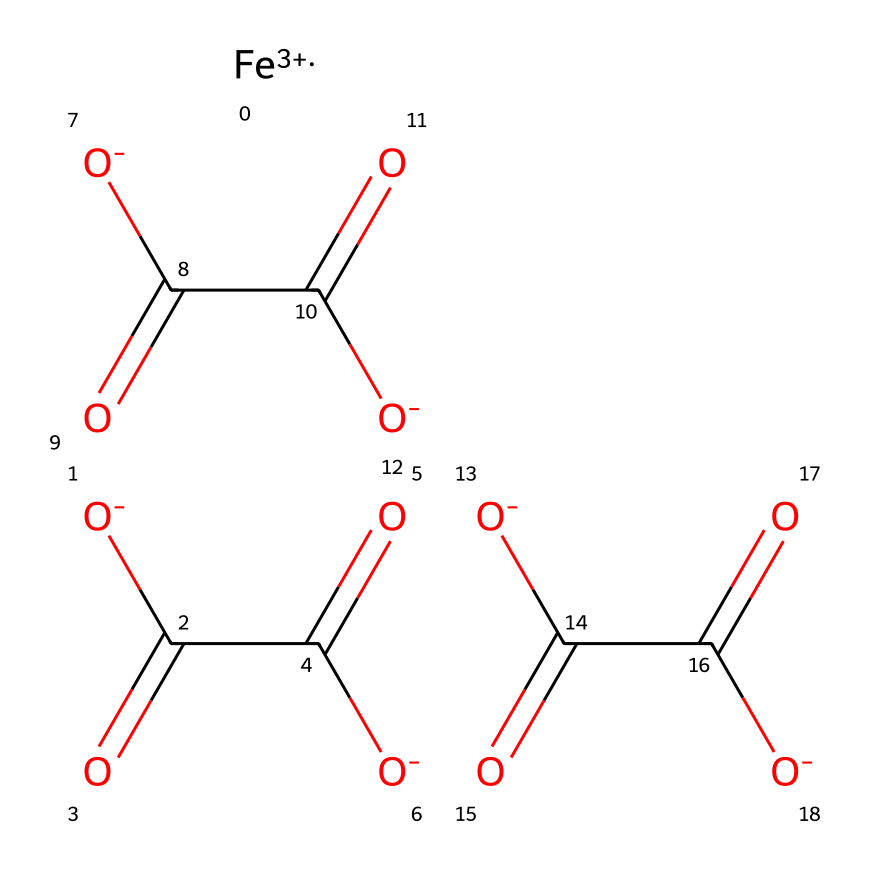What is the central metal ion in this coordination compound? The central metal ion can be identified by looking for the positively charged species in the structure. In this case, the positive charge corresponds to the iron (Fe) in the oxidation state of +3.
Answer: iron(III) How many oxalate ligands are present in the structure? The oxalate ligand is represented by the segment “C(=O)C(=O)[O-]”, which appears three times in the structure. Thus, we can count three instances of this ligand.
Answer: three What type of coordination environment does iron(III) have in this compound? The coordination environment can be discerned by examining the number of ligands attached to the central metal ion. Here, iron(III) is coordinated to three bidentate oxalate ligands, indicating an octahedral coordination geometry.
Answer: octahedral What is the overall charge of the coordination compound? To determine the overall charge, we sum the charges of the central metal and the ligands. Iron(III) contributes +3, and each oxalate contributes -2 for a total of -6 from three oxalate ligands. Thus, the overall charge is +3 - 6 = -3.
Answer: -3 How does the presence of oxalate ligands influence the properties of this coordination compound? Oxalate is a bidentate ligand which means it can coordinate to the metal ion through two bonding sites. This enhances the stability of the coordination complex and alters its solubility, reactivity, and other properties relative to the metal ion alone.
Answer: enhances stability What type of isomerism might be present in this compound? This coordination compound may exhibit geometrical isomerism due to the arrangement of oxalate ligands around the central Fe(III) ion. Variations in the spatial orientation of those bidentate ligands can lead to distinct isomers.
Answer: geometrical isomerism 